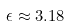Convert formula to latex. <formula><loc_0><loc_0><loc_500><loc_500>\epsilon \approx 3 . 1 8</formula> 